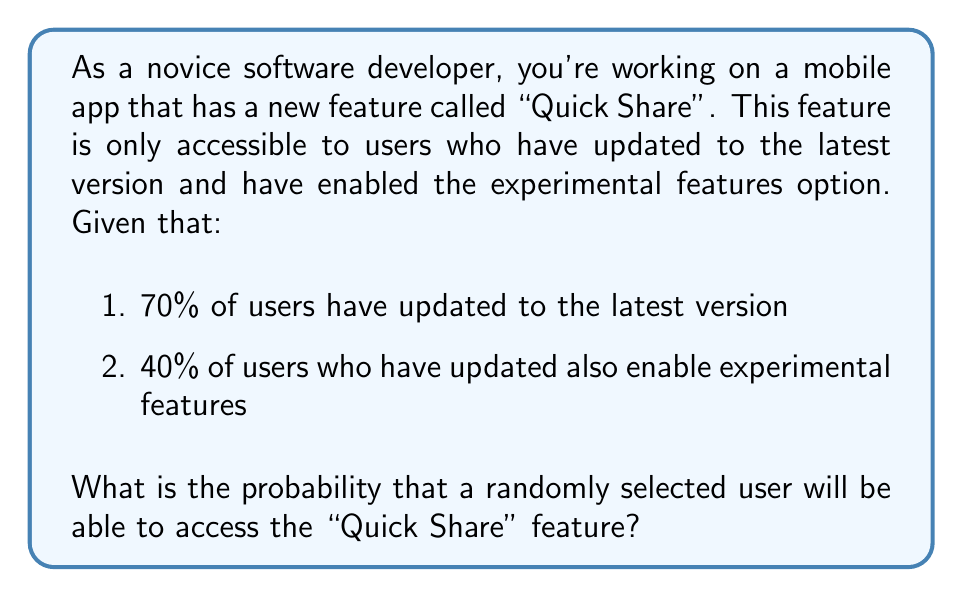Can you solve this math problem? Let's approach this step-by-step:

1) First, we need to identify the two conditions that must be met for a user to access the "Quick Share" feature:
   a) The user must have updated to the latest version
   b) The user must have enabled experimental features

2) We're given two probabilities:
   - $P(\text{Updated}) = 0.70$ (70% of users have updated)
   - $P(\text{Experimental} | \text{Updated}) = 0.40$ (40% of updated users enable experimental features)

3) To find the probability of both events occurring, we use the multiplication rule of probability:

   $P(\text{Updated and Experimental}) = P(\text{Updated}) \times P(\text{Experimental} | \text{Updated})$

4) Substituting the values:

   $P(\text{Updated and Experimental}) = 0.70 \times 0.40 = 0.28$

5) Therefore, the probability of a randomly selected user being able to access the "Quick Share" feature is 0.28 or 28%.

This problem demonstrates the application of conditional probability in software development scenarios, which is crucial for estimating feature availability and user experience in app development.
Answer: 0.28 